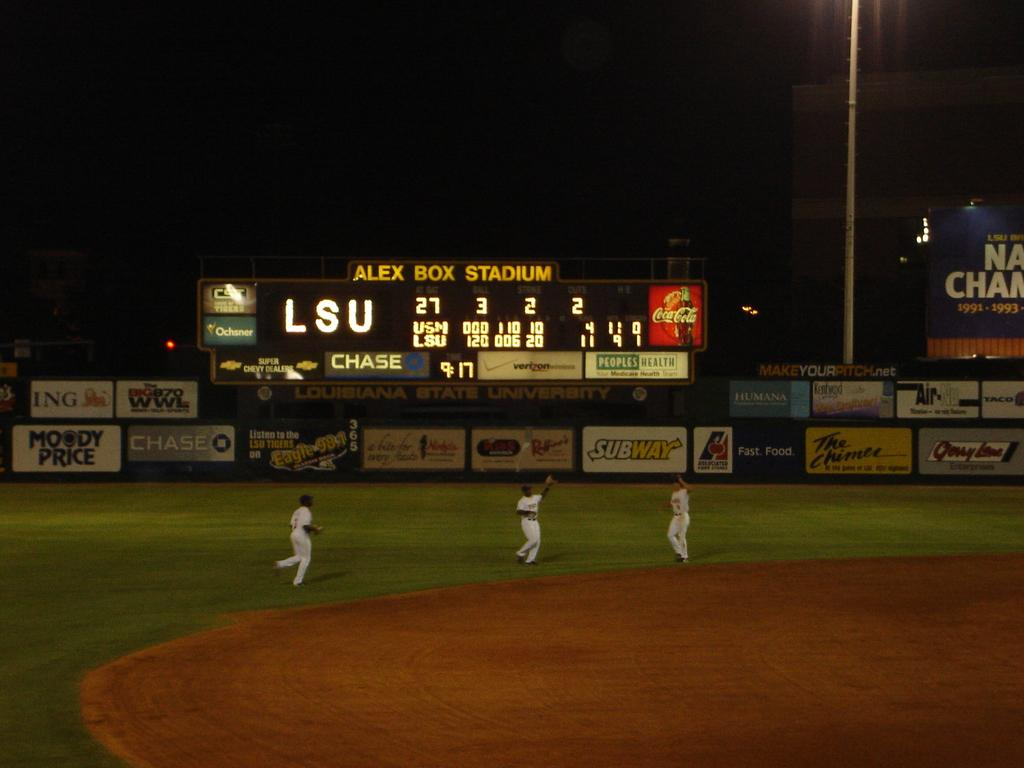<image>
Give a short and clear explanation of the subsequent image. Alex Box Stadium that is on a scoreboard 